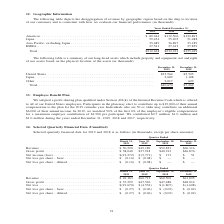According to A10 Networks's financial document, What data is shown in the table? disaggregation of revenue by geographic region. The document states: "The following table depicts the disaggregation of revenue by geographic region based on the ship to location of our customers and is consistent with h..." Also, What is the units for the data shown in the table? According to the financial document, in thousands. The relevant text states: "t with how we evaluate our financial performance (in thousands):..." Also, What is the total revenue earned by the company in 2019? According to the financial document, $212,628. The relevant text states: "Total . $212,628 $232,223 $235,429..." Also, can you calculate: What is the total revenue earned by the company between 2017 to 2019? Based on the calculation: $212,628 + $232,223 + $235,429 , the result is 680280 (in thousands). This is based on the information: "Total . $212,628 $232,223 $235,429 Total . $212,628 $232,223 $235,429 Total . $212,628 $232,223 $235,429..." The key data points involved are: 212,628, 232,223, 235,429. Also, can you calculate: What is the total revenue earned in EMEA between 2017 to 2019? Based on the calculation: 27,541 + 27,615 + 27,859, the result is 83015 (in thousands). This is based on the information: "uding Japan . 35,689 36,897 33,189 EMEA. . 27,541 27,615 27,859 c, excluding Japan . 35,689 36,897 33,189 EMEA. . 27,541 27,615 27,859 apan . 35,689 36,897 33,189 EMEA. . 27,541 27,615 27,859..." The key data points involved are: 27,541, 27,615, 27,859. Also, can you calculate: What is the change in total revenue between 2018 to 2019? To answer this question, I need to perform calculations using the financial data. The calculation is: ($212,628 - $232,223)/$232,223 , which equals -8.44 (percentage). This is based on the information: "Total . $212,628 $232,223 $235,429 Total . $212,628 $232,223 $235,429..." The key data points involved are: 212,628, 232,223. 